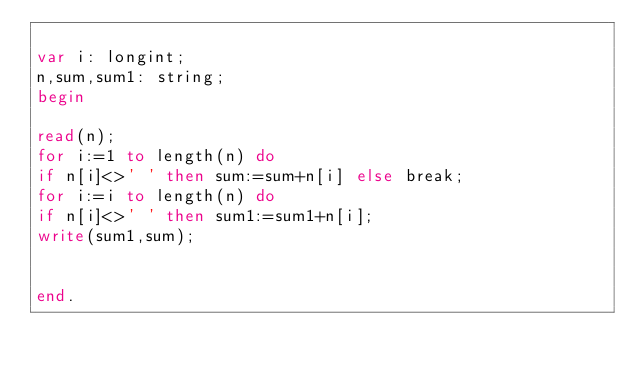<code> <loc_0><loc_0><loc_500><loc_500><_Pascal_>
var i: longint;
n,sum,sum1: string;
begin

read(n);  
for i:=1 to length(n) do
if n[i]<>' ' then sum:=sum+n[i] else break;
for i:=i to length(n) do
if n[i]<>' ' then sum1:=sum1+n[i];
write(sum1,sum);


end.</code> 